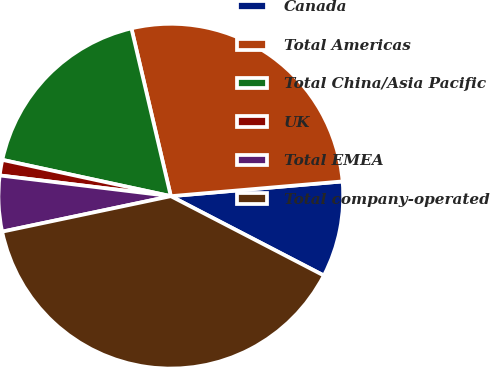Convert chart to OTSL. <chart><loc_0><loc_0><loc_500><loc_500><pie_chart><fcel>Canada<fcel>Total Americas<fcel>Total China/Asia Pacific<fcel>UK<fcel>Total EMEA<fcel>Total company-operated<nl><fcel>8.98%<fcel>27.31%<fcel>17.95%<fcel>1.46%<fcel>5.22%<fcel>39.09%<nl></chart> 